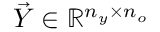<formula> <loc_0><loc_0><loc_500><loc_500>\vec { Y } \in \mathbb { R } ^ { n _ { y } \times n _ { o } }</formula> 